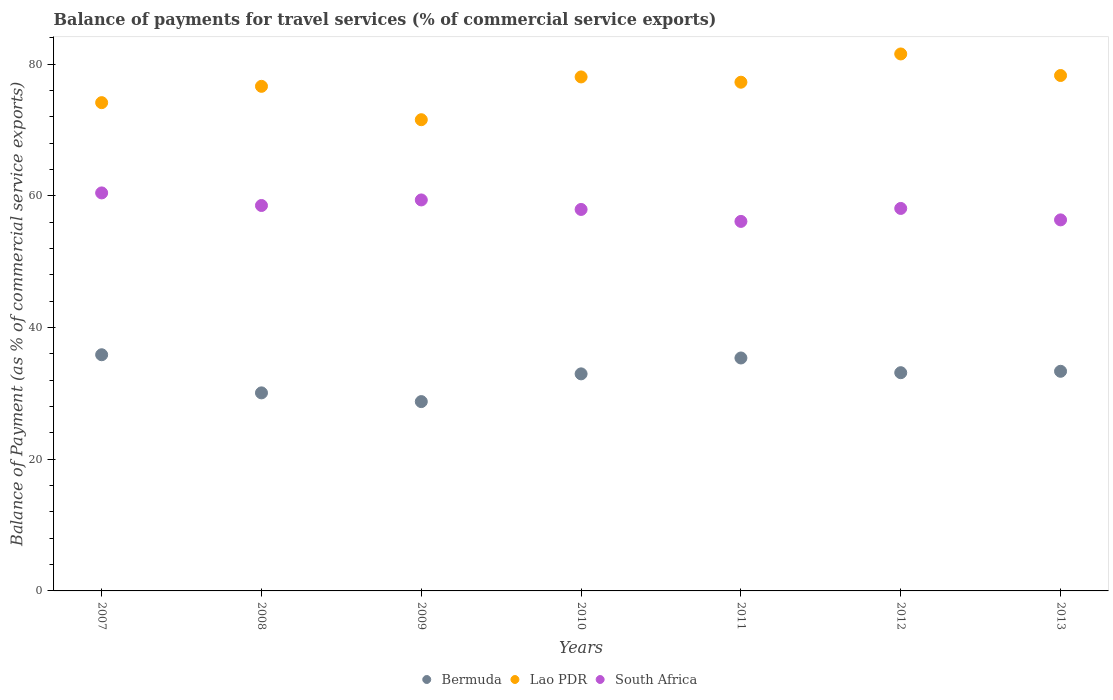How many different coloured dotlines are there?
Provide a short and direct response. 3. What is the balance of payments for travel services in Bermuda in 2009?
Offer a very short reply. 28.76. Across all years, what is the maximum balance of payments for travel services in Bermuda?
Offer a very short reply. 35.88. Across all years, what is the minimum balance of payments for travel services in Bermuda?
Give a very brief answer. 28.76. What is the total balance of payments for travel services in Lao PDR in the graph?
Offer a very short reply. 537.66. What is the difference between the balance of payments for travel services in Lao PDR in 2007 and that in 2009?
Your answer should be compact. 2.59. What is the difference between the balance of payments for travel services in Bermuda in 2013 and the balance of payments for travel services in Lao PDR in 2007?
Offer a terse response. -40.81. What is the average balance of payments for travel services in South Africa per year?
Your response must be concise. 58.14. In the year 2012, what is the difference between the balance of payments for travel services in South Africa and balance of payments for travel services in Bermuda?
Your answer should be very brief. 24.95. In how many years, is the balance of payments for travel services in Lao PDR greater than 80 %?
Your answer should be very brief. 1. What is the ratio of the balance of payments for travel services in South Africa in 2007 to that in 2008?
Ensure brevity in your answer.  1.03. Is the difference between the balance of payments for travel services in South Africa in 2007 and 2009 greater than the difference between the balance of payments for travel services in Bermuda in 2007 and 2009?
Ensure brevity in your answer.  No. What is the difference between the highest and the second highest balance of payments for travel services in South Africa?
Offer a terse response. 1.07. What is the difference between the highest and the lowest balance of payments for travel services in Bermuda?
Give a very brief answer. 7.12. Is the sum of the balance of payments for travel services in South Africa in 2009 and 2011 greater than the maximum balance of payments for travel services in Lao PDR across all years?
Your response must be concise. Yes. Is the balance of payments for travel services in South Africa strictly greater than the balance of payments for travel services in Bermuda over the years?
Your response must be concise. Yes. Is the balance of payments for travel services in Bermuda strictly less than the balance of payments for travel services in South Africa over the years?
Make the answer very short. Yes. How many dotlines are there?
Your response must be concise. 3. What is the difference between two consecutive major ticks on the Y-axis?
Your answer should be very brief. 20. Where does the legend appear in the graph?
Provide a short and direct response. Bottom center. How many legend labels are there?
Offer a very short reply. 3. How are the legend labels stacked?
Ensure brevity in your answer.  Horizontal. What is the title of the graph?
Provide a short and direct response. Balance of payments for travel services (% of commercial service exports). Does "European Union" appear as one of the legend labels in the graph?
Make the answer very short. No. What is the label or title of the Y-axis?
Offer a terse response. Balance of Payment (as % of commercial service exports). What is the Balance of Payment (as % of commercial service exports) of Bermuda in 2007?
Offer a terse response. 35.88. What is the Balance of Payment (as % of commercial service exports) of Lao PDR in 2007?
Offer a very short reply. 74.18. What is the Balance of Payment (as % of commercial service exports) of South Africa in 2007?
Make the answer very short. 60.46. What is the Balance of Payment (as % of commercial service exports) of Bermuda in 2008?
Provide a succinct answer. 30.09. What is the Balance of Payment (as % of commercial service exports) of Lao PDR in 2008?
Keep it short and to the point. 76.65. What is the Balance of Payment (as % of commercial service exports) in South Africa in 2008?
Ensure brevity in your answer.  58.55. What is the Balance of Payment (as % of commercial service exports) in Bermuda in 2009?
Provide a succinct answer. 28.76. What is the Balance of Payment (as % of commercial service exports) in Lao PDR in 2009?
Provide a short and direct response. 71.58. What is the Balance of Payment (as % of commercial service exports) of South Africa in 2009?
Make the answer very short. 59.4. What is the Balance of Payment (as % of commercial service exports) in Bermuda in 2010?
Keep it short and to the point. 32.98. What is the Balance of Payment (as % of commercial service exports) of Lao PDR in 2010?
Provide a short and direct response. 78.08. What is the Balance of Payment (as % of commercial service exports) of South Africa in 2010?
Provide a short and direct response. 57.95. What is the Balance of Payment (as % of commercial service exports) in Bermuda in 2011?
Ensure brevity in your answer.  35.39. What is the Balance of Payment (as % of commercial service exports) in Lao PDR in 2011?
Offer a terse response. 77.28. What is the Balance of Payment (as % of commercial service exports) of South Africa in 2011?
Offer a terse response. 56.14. What is the Balance of Payment (as % of commercial service exports) in Bermuda in 2012?
Make the answer very short. 33.15. What is the Balance of Payment (as % of commercial service exports) in Lao PDR in 2012?
Offer a terse response. 81.57. What is the Balance of Payment (as % of commercial service exports) of South Africa in 2012?
Offer a terse response. 58.11. What is the Balance of Payment (as % of commercial service exports) in Bermuda in 2013?
Keep it short and to the point. 33.37. What is the Balance of Payment (as % of commercial service exports) in Lao PDR in 2013?
Ensure brevity in your answer.  78.3. What is the Balance of Payment (as % of commercial service exports) in South Africa in 2013?
Make the answer very short. 56.37. Across all years, what is the maximum Balance of Payment (as % of commercial service exports) of Bermuda?
Your answer should be very brief. 35.88. Across all years, what is the maximum Balance of Payment (as % of commercial service exports) of Lao PDR?
Keep it short and to the point. 81.57. Across all years, what is the maximum Balance of Payment (as % of commercial service exports) of South Africa?
Your answer should be compact. 60.46. Across all years, what is the minimum Balance of Payment (as % of commercial service exports) in Bermuda?
Your answer should be very brief. 28.76. Across all years, what is the minimum Balance of Payment (as % of commercial service exports) of Lao PDR?
Your answer should be very brief. 71.58. Across all years, what is the minimum Balance of Payment (as % of commercial service exports) in South Africa?
Offer a very short reply. 56.14. What is the total Balance of Payment (as % of commercial service exports) in Bermuda in the graph?
Your answer should be very brief. 229.61. What is the total Balance of Payment (as % of commercial service exports) of Lao PDR in the graph?
Provide a short and direct response. 537.66. What is the total Balance of Payment (as % of commercial service exports) in South Africa in the graph?
Offer a terse response. 406.98. What is the difference between the Balance of Payment (as % of commercial service exports) in Bermuda in 2007 and that in 2008?
Ensure brevity in your answer.  5.79. What is the difference between the Balance of Payment (as % of commercial service exports) in Lao PDR in 2007 and that in 2008?
Keep it short and to the point. -2.48. What is the difference between the Balance of Payment (as % of commercial service exports) of South Africa in 2007 and that in 2008?
Your answer should be very brief. 1.91. What is the difference between the Balance of Payment (as % of commercial service exports) of Bermuda in 2007 and that in 2009?
Ensure brevity in your answer.  7.12. What is the difference between the Balance of Payment (as % of commercial service exports) of Lao PDR in 2007 and that in 2009?
Ensure brevity in your answer.  2.59. What is the difference between the Balance of Payment (as % of commercial service exports) in South Africa in 2007 and that in 2009?
Offer a terse response. 1.07. What is the difference between the Balance of Payment (as % of commercial service exports) in Bermuda in 2007 and that in 2010?
Ensure brevity in your answer.  2.9. What is the difference between the Balance of Payment (as % of commercial service exports) in Lao PDR in 2007 and that in 2010?
Your response must be concise. -3.91. What is the difference between the Balance of Payment (as % of commercial service exports) of South Africa in 2007 and that in 2010?
Keep it short and to the point. 2.51. What is the difference between the Balance of Payment (as % of commercial service exports) of Bermuda in 2007 and that in 2011?
Offer a terse response. 0.49. What is the difference between the Balance of Payment (as % of commercial service exports) in Lao PDR in 2007 and that in 2011?
Offer a terse response. -3.1. What is the difference between the Balance of Payment (as % of commercial service exports) of South Africa in 2007 and that in 2011?
Make the answer very short. 4.33. What is the difference between the Balance of Payment (as % of commercial service exports) of Bermuda in 2007 and that in 2012?
Your answer should be compact. 2.73. What is the difference between the Balance of Payment (as % of commercial service exports) of Lao PDR in 2007 and that in 2012?
Keep it short and to the point. -7.4. What is the difference between the Balance of Payment (as % of commercial service exports) of South Africa in 2007 and that in 2012?
Your answer should be compact. 2.36. What is the difference between the Balance of Payment (as % of commercial service exports) of Bermuda in 2007 and that in 2013?
Provide a short and direct response. 2.51. What is the difference between the Balance of Payment (as % of commercial service exports) of Lao PDR in 2007 and that in 2013?
Your answer should be compact. -4.12. What is the difference between the Balance of Payment (as % of commercial service exports) in South Africa in 2007 and that in 2013?
Make the answer very short. 4.1. What is the difference between the Balance of Payment (as % of commercial service exports) of Bermuda in 2008 and that in 2009?
Make the answer very short. 1.33. What is the difference between the Balance of Payment (as % of commercial service exports) of Lao PDR in 2008 and that in 2009?
Offer a very short reply. 5.07. What is the difference between the Balance of Payment (as % of commercial service exports) of South Africa in 2008 and that in 2009?
Your answer should be very brief. -0.84. What is the difference between the Balance of Payment (as % of commercial service exports) of Bermuda in 2008 and that in 2010?
Your answer should be very brief. -2.89. What is the difference between the Balance of Payment (as % of commercial service exports) in Lao PDR in 2008 and that in 2010?
Your answer should be compact. -1.43. What is the difference between the Balance of Payment (as % of commercial service exports) in South Africa in 2008 and that in 2010?
Provide a short and direct response. 0.6. What is the difference between the Balance of Payment (as % of commercial service exports) of Bermuda in 2008 and that in 2011?
Keep it short and to the point. -5.3. What is the difference between the Balance of Payment (as % of commercial service exports) of Lao PDR in 2008 and that in 2011?
Ensure brevity in your answer.  -0.63. What is the difference between the Balance of Payment (as % of commercial service exports) of South Africa in 2008 and that in 2011?
Ensure brevity in your answer.  2.42. What is the difference between the Balance of Payment (as % of commercial service exports) in Bermuda in 2008 and that in 2012?
Offer a terse response. -3.06. What is the difference between the Balance of Payment (as % of commercial service exports) in Lao PDR in 2008 and that in 2012?
Ensure brevity in your answer.  -4.92. What is the difference between the Balance of Payment (as % of commercial service exports) in South Africa in 2008 and that in 2012?
Keep it short and to the point. 0.45. What is the difference between the Balance of Payment (as % of commercial service exports) in Bermuda in 2008 and that in 2013?
Your answer should be compact. -3.28. What is the difference between the Balance of Payment (as % of commercial service exports) of Lao PDR in 2008 and that in 2013?
Ensure brevity in your answer.  -1.65. What is the difference between the Balance of Payment (as % of commercial service exports) of South Africa in 2008 and that in 2013?
Give a very brief answer. 2.19. What is the difference between the Balance of Payment (as % of commercial service exports) of Bermuda in 2009 and that in 2010?
Provide a short and direct response. -4.22. What is the difference between the Balance of Payment (as % of commercial service exports) in Lao PDR in 2009 and that in 2010?
Give a very brief answer. -6.5. What is the difference between the Balance of Payment (as % of commercial service exports) in South Africa in 2009 and that in 2010?
Make the answer very short. 1.45. What is the difference between the Balance of Payment (as % of commercial service exports) of Bermuda in 2009 and that in 2011?
Your answer should be compact. -6.63. What is the difference between the Balance of Payment (as % of commercial service exports) of Lao PDR in 2009 and that in 2011?
Offer a terse response. -5.7. What is the difference between the Balance of Payment (as % of commercial service exports) in South Africa in 2009 and that in 2011?
Provide a succinct answer. 3.26. What is the difference between the Balance of Payment (as % of commercial service exports) in Bermuda in 2009 and that in 2012?
Your response must be concise. -4.39. What is the difference between the Balance of Payment (as % of commercial service exports) of Lao PDR in 2009 and that in 2012?
Your answer should be very brief. -9.99. What is the difference between the Balance of Payment (as % of commercial service exports) of South Africa in 2009 and that in 2012?
Keep it short and to the point. 1.29. What is the difference between the Balance of Payment (as % of commercial service exports) of Bermuda in 2009 and that in 2013?
Offer a terse response. -4.61. What is the difference between the Balance of Payment (as % of commercial service exports) of Lao PDR in 2009 and that in 2013?
Offer a very short reply. -6.72. What is the difference between the Balance of Payment (as % of commercial service exports) in South Africa in 2009 and that in 2013?
Your answer should be compact. 3.03. What is the difference between the Balance of Payment (as % of commercial service exports) of Bermuda in 2010 and that in 2011?
Offer a terse response. -2.41. What is the difference between the Balance of Payment (as % of commercial service exports) in Lao PDR in 2010 and that in 2011?
Make the answer very short. 0.8. What is the difference between the Balance of Payment (as % of commercial service exports) of South Africa in 2010 and that in 2011?
Ensure brevity in your answer.  1.82. What is the difference between the Balance of Payment (as % of commercial service exports) of Bermuda in 2010 and that in 2012?
Your answer should be very brief. -0.18. What is the difference between the Balance of Payment (as % of commercial service exports) of Lao PDR in 2010 and that in 2012?
Make the answer very short. -3.49. What is the difference between the Balance of Payment (as % of commercial service exports) in South Africa in 2010 and that in 2012?
Your response must be concise. -0.15. What is the difference between the Balance of Payment (as % of commercial service exports) of Bermuda in 2010 and that in 2013?
Your answer should be very brief. -0.39. What is the difference between the Balance of Payment (as % of commercial service exports) in Lao PDR in 2010 and that in 2013?
Make the answer very short. -0.22. What is the difference between the Balance of Payment (as % of commercial service exports) in South Africa in 2010 and that in 2013?
Offer a terse response. 1.58. What is the difference between the Balance of Payment (as % of commercial service exports) in Bermuda in 2011 and that in 2012?
Offer a terse response. 2.24. What is the difference between the Balance of Payment (as % of commercial service exports) of Lao PDR in 2011 and that in 2012?
Ensure brevity in your answer.  -4.29. What is the difference between the Balance of Payment (as % of commercial service exports) in South Africa in 2011 and that in 2012?
Ensure brevity in your answer.  -1.97. What is the difference between the Balance of Payment (as % of commercial service exports) of Bermuda in 2011 and that in 2013?
Give a very brief answer. 2.02. What is the difference between the Balance of Payment (as % of commercial service exports) of Lao PDR in 2011 and that in 2013?
Your answer should be compact. -1.02. What is the difference between the Balance of Payment (as % of commercial service exports) of South Africa in 2011 and that in 2013?
Your answer should be compact. -0.23. What is the difference between the Balance of Payment (as % of commercial service exports) in Bermuda in 2012 and that in 2013?
Ensure brevity in your answer.  -0.21. What is the difference between the Balance of Payment (as % of commercial service exports) in Lao PDR in 2012 and that in 2013?
Give a very brief answer. 3.27. What is the difference between the Balance of Payment (as % of commercial service exports) in South Africa in 2012 and that in 2013?
Offer a terse response. 1.74. What is the difference between the Balance of Payment (as % of commercial service exports) in Bermuda in 2007 and the Balance of Payment (as % of commercial service exports) in Lao PDR in 2008?
Give a very brief answer. -40.78. What is the difference between the Balance of Payment (as % of commercial service exports) of Bermuda in 2007 and the Balance of Payment (as % of commercial service exports) of South Africa in 2008?
Give a very brief answer. -22.67. What is the difference between the Balance of Payment (as % of commercial service exports) of Lao PDR in 2007 and the Balance of Payment (as % of commercial service exports) of South Africa in 2008?
Offer a terse response. 15.62. What is the difference between the Balance of Payment (as % of commercial service exports) of Bermuda in 2007 and the Balance of Payment (as % of commercial service exports) of Lao PDR in 2009?
Your answer should be compact. -35.71. What is the difference between the Balance of Payment (as % of commercial service exports) in Bermuda in 2007 and the Balance of Payment (as % of commercial service exports) in South Africa in 2009?
Provide a succinct answer. -23.52. What is the difference between the Balance of Payment (as % of commercial service exports) of Lao PDR in 2007 and the Balance of Payment (as % of commercial service exports) of South Africa in 2009?
Your answer should be compact. 14.78. What is the difference between the Balance of Payment (as % of commercial service exports) of Bermuda in 2007 and the Balance of Payment (as % of commercial service exports) of Lao PDR in 2010?
Offer a terse response. -42.21. What is the difference between the Balance of Payment (as % of commercial service exports) in Bermuda in 2007 and the Balance of Payment (as % of commercial service exports) in South Africa in 2010?
Offer a terse response. -22.07. What is the difference between the Balance of Payment (as % of commercial service exports) of Lao PDR in 2007 and the Balance of Payment (as % of commercial service exports) of South Africa in 2010?
Give a very brief answer. 16.23. What is the difference between the Balance of Payment (as % of commercial service exports) of Bermuda in 2007 and the Balance of Payment (as % of commercial service exports) of Lao PDR in 2011?
Offer a very short reply. -41.4. What is the difference between the Balance of Payment (as % of commercial service exports) of Bermuda in 2007 and the Balance of Payment (as % of commercial service exports) of South Africa in 2011?
Offer a terse response. -20.26. What is the difference between the Balance of Payment (as % of commercial service exports) in Lao PDR in 2007 and the Balance of Payment (as % of commercial service exports) in South Africa in 2011?
Your answer should be very brief. 18.04. What is the difference between the Balance of Payment (as % of commercial service exports) in Bermuda in 2007 and the Balance of Payment (as % of commercial service exports) in Lao PDR in 2012?
Your answer should be very brief. -45.7. What is the difference between the Balance of Payment (as % of commercial service exports) of Bermuda in 2007 and the Balance of Payment (as % of commercial service exports) of South Africa in 2012?
Provide a short and direct response. -22.23. What is the difference between the Balance of Payment (as % of commercial service exports) of Lao PDR in 2007 and the Balance of Payment (as % of commercial service exports) of South Africa in 2012?
Ensure brevity in your answer.  16.07. What is the difference between the Balance of Payment (as % of commercial service exports) of Bermuda in 2007 and the Balance of Payment (as % of commercial service exports) of Lao PDR in 2013?
Keep it short and to the point. -42.42. What is the difference between the Balance of Payment (as % of commercial service exports) in Bermuda in 2007 and the Balance of Payment (as % of commercial service exports) in South Africa in 2013?
Offer a terse response. -20.49. What is the difference between the Balance of Payment (as % of commercial service exports) of Lao PDR in 2007 and the Balance of Payment (as % of commercial service exports) of South Africa in 2013?
Your response must be concise. 17.81. What is the difference between the Balance of Payment (as % of commercial service exports) of Bermuda in 2008 and the Balance of Payment (as % of commercial service exports) of Lao PDR in 2009?
Your response must be concise. -41.5. What is the difference between the Balance of Payment (as % of commercial service exports) in Bermuda in 2008 and the Balance of Payment (as % of commercial service exports) in South Africa in 2009?
Make the answer very short. -29.31. What is the difference between the Balance of Payment (as % of commercial service exports) of Lao PDR in 2008 and the Balance of Payment (as % of commercial service exports) of South Africa in 2009?
Provide a succinct answer. 17.26. What is the difference between the Balance of Payment (as % of commercial service exports) in Bermuda in 2008 and the Balance of Payment (as % of commercial service exports) in Lao PDR in 2010?
Your response must be concise. -48. What is the difference between the Balance of Payment (as % of commercial service exports) in Bermuda in 2008 and the Balance of Payment (as % of commercial service exports) in South Africa in 2010?
Your answer should be compact. -27.86. What is the difference between the Balance of Payment (as % of commercial service exports) of Lao PDR in 2008 and the Balance of Payment (as % of commercial service exports) of South Africa in 2010?
Your answer should be compact. 18.7. What is the difference between the Balance of Payment (as % of commercial service exports) in Bermuda in 2008 and the Balance of Payment (as % of commercial service exports) in Lao PDR in 2011?
Your answer should be very brief. -47.19. What is the difference between the Balance of Payment (as % of commercial service exports) in Bermuda in 2008 and the Balance of Payment (as % of commercial service exports) in South Africa in 2011?
Your answer should be compact. -26.05. What is the difference between the Balance of Payment (as % of commercial service exports) in Lao PDR in 2008 and the Balance of Payment (as % of commercial service exports) in South Africa in 2011?
Ensure brevity in your answer.  20.52. What is the difference between the Balance of Payment (as % of commercial service exports) in Bermuda in 2008 and the Balance of Payment (as % of commercial service exports) in Lao PDR in 2012?
Offer a terse response. -51.49. What is the difference between the Balance of Payment (as % of commercial service exports) in Bermuda in 2008 and the Balance of Payment (as % of commercial service exports) in South Africa in 2012?
Keep it short and to the point. -28.02. What is the difference between the Balance of Payment (as % of commercial service exports) of Lao PDR in 2008 and the Balance of Payment (as % of commercial service exports) of South Africa in 2012?
Offer a very short reply. 18.55. What is the difference between the Balance of Payment (as % of commercial service exports) in Bermuda in 2008 and the Balance of Payment (as % of commercial service exports) in Lao PDR in 2013?
Ensure brevity in your answer.  -48.21. What is the difference between the Balance of Payment (as % of commercial service exports) of Bermuda in 2008 and the Balance of Payment (as % of commercial service exports) of South Africa in 2013?
Offer a very short reply. -26.28. What is the difference between the Balance of Payment (as % of commercial service exports) in Lao PDR in 2008 and the Balance of Payment (as % of commercial service exports) in South Africa in 2013?
Give a very brief answer. 20.29. What is the difference between the Balance of Payment (as % of commercial service exports) of Bermuda in 2009 and the Balance of Payment (as % of commercial service exports) of Lao PDR in 2010?
Make the answer very short. -49.32. What is the difference between the Balance of Payment (as % of commercial service exports) of Bermuda in 2009 and the Balance of Payment (as % of commercial service exports) of South Africa in 2010?
Your answer should be very brief. -29.19. What is the difference between the Balance of Payment (as % of commercial service exports) of Lao PDR in 2009 and the Balance of Payment (as % of commercial service exports) of South Africa in 2010?
Keep it short and to the point. 13.63. What is the difference between the Balance of Payment (as % of commercial service exports) of Bermuda in 2009 and the Balance of Payment (as % of commercial service exports) of Lao PDR in 2011?
Make the answer very short. -48.52. What is the difference between the Balance of Payment (as % of commercial service exports) of Bermuda in 2009 and the Balance of Payment (as % of commercial service exports) of South Africa in 2011?
Your answer should be compact. -27.38. What is the difference between the Balance of Payment (as % of commercial service exports) of Lao PDR in 2009 and the Balance of Payment (as % of commercial service exports) of South Africa in 2011?
Your response must be concise. 15.45. What is the difference between the Balance of Payment (as % of commercial service exports) in Bermuda in 2009 and the Balance of Payment (as % of commercial service exports) in Lao PDR in 2012?
Make the answer very short. -52.81. What is the difference between the Balance of Payment (as % of commercial service exports) of Bermuda in 2009 and the Balance of Payment (as % of commercial service exports) of South Africa in 2012?
Give a very brief answer. -29.35. What is the difference between the Balance of Payment (as % of commercial service exports) in Lao PDR in 2009 and the Balance of Payment (as % of commercial service exports) in South Africa in 2012?
Ensure brevity in your answer.  13.48. What is the difference between the Balance of Payment (as % of commercial service exports) of Bermuda in 2009 and the Balance of Payment (as % of commercial service exports) of Lao PDR in 2013?
Provide a succinct answer. -49.54. What is the difference between the Balance of Payment (as % of commercial service exports) of Bermuda in 2009 and the Balance of Payment (as % of commercial service exports) of South Africa in 2013?
Your response must be concise. -27.61. What is the difference between the Balance of Payment (as % of commercial service exports) of Lao PDR in 2009 and the Balance of Payment (as % of commercial service exports) of South Africa in 2013?
Your response must be concise. 15.22. What is the difference between the Balance of Payment (as % of commercial service exports) in Bermuda in 2010 and the Balance of Payment (as % of commercial service exports) in Lao PDR in 2011?
Your response must be concise. -44.31. What is the difference between the Balance of Payment (as % of commercial service exports) in Bermuda in 2010 and the Balance of Payment (as % of commercial service exports) in South Africa in 2011?
Give a very brief answer. -23.16. What is the difference between the Balance of Payment (as % of commercial service exports) in Lao PDR in 2010 and the Balance of Payment (as % of commercial service exports) in South Africa in 2011?
Make the answer very short. 21.95. What is the difference between the Balance of Payment (as % of commercial service exports) of Bermuda in 2010 and the Balance of Payment (as % of commercial service exports) of Lao PDR in 2012?
Ensure brevity in your answer.  -48.6. What is the difference between the Balance of Payment (as % of commercial service exports) of Bermuda in 2010 and the Balance of Payment (as % of commercial service exports) of South Africa in 2012?
Provide a succinct answer. -25.13. What is the difference between the Balance of Payment (as % of commercial service exports) of Lao PDR in 2010 and the Balance of Payment (as % of commercial service exports) of South Africa in 2012?
Your answer should be very brief. 19.98. What is the difference between the Balance of Payment (as % of commercial service exports) in Bermuda in 2010 and the Balance of Payment (as % of commercial service exports) in Lao PDR in 2013?
Your answer should be very brief. -45.33. What is the difference between the Balance of Payment (as % of commercial service exports) of Bermuda in 2010 and the Balance of Payment (as % of commercial service exports) of South Africa in 2013?
Provide a succinct answer. -23.39. What is the difference between the Balance of Payment (as % of commercial service exports) in Lao PDR in 2010 and the Balance of Payment (as % of commercial service exports) in South Africa in 2013?
Provide a short and direct response. 21.72. What is the difference between the Balance of Payment (as % of commercial service exports) of Bermuda in 2011 and the Balance of Payment (as % of commercial service exports) of Lao PDR in 2012?
Offer a very short reply. -46.19. What is the difference between the Balance of Payment (as % of commercial service exports) of Bermuda in 2011 and the Balance of Payment (as % of commercial service exports) of South Africa in 2012?
Your answer should be very brief. -22.72. What is the difference between the Balance of Payment (as % of commercial service exports) in Lao PDR in 2011 and the Balance of Payment (as % of commercial service exports) in South Africa in 2012?
Your answer should be very brief. 19.18. What is the difference between the Balance of Payment (as % of commercial service exports) of Bermuda in 2011 and the Balance of Payment (as % of commercial service exports) of Lao PDR in 2013?
Offer a very short reply. -42.91. What is the difference between the Balance of Payment (as % of commercial service exports) of Bermuda in 2011 and the Balance of Payment (as % of commercial service exports) of South Africa in 2013?
Your answer should be compact. -20.98. What is the difference between the Balance of Payment (as % of commercial service exports) in Lao PDR in 2011 and the Balance of Payment (as % of commercial service exports) in South Africa in 2013?
Your answer should be very brief. 20.91. What is the difference between the Balance of Payment (as % of commercial service exports) of Bermuda in 2012 and the Balance of Payment (as % of commercial service exports) of Lao PDR in 2013?
Offer a very short reply. -45.15. What is the difference between the Balance of Payment (as % of commercial service exports) in Bermuda in 2012 and the Balance of Payment (as % of commercial service exports) in South Africa in 2013?
Provide a succinct answer. -23.22. What is the difference between the Balance of Payment (as % of commercial service exports) of Lao PDR in 2012 and the Balance of Payment (as % of commercial service exports) of South Africa in 2013?
Provide a short and direct response. 25.21. What is the average Balance of Payment (as % of commercial service exports) of Bermuda per year?
Your answer should be compact. 32.8. What is the average Balance of Payment (as % of commercial service exports) of Lao PDR per year?
Your response must be concise. 76.81. What is the average Balance of Payment (as % of commercial service exports) in South Africa per year?
Give a very brief answer. 58.14. In the year 2007, what is the difference between the Balance of Payment (as % of commercial service exports) in Bermuda and Balance of Payment (as % of commercial service exports) in Lao PDR?
Offer a very short reply. -38.3. In the year 2007, what is the difference between the Balance of Payment (as % of commercial service exports) in Bermuda and Balance of Payment (as % of commercial service exports) in South Africa?
Offer a very short reply. -24.59. In the year 2007, what is the difference between the Balance of Payment (as % of commercial service exports) of Lao PDR and Balance of Payment (as % of commercial service exports) of South Africa?
Make the answer very short. 13.71. In the year 2008, what is the difference between the Balance of Payment (as % of commercial service exports) in Bermuda and Balance of Payment (as % of commercial service exports) in Lao PDR?
Offer a terse response. -46.57. In the year 2008, what is the difference between the Balance of Payment (as % of commercial service exports) of Bermuda and Balance of Payment (as % of commercial service exports) of South Africa?
Your answer should be compact. -28.47. In the year 2008, what is the difference between the Balance of Payment (as % of commercial service exports) of Lao PDR and Balance of Payment (as % of commercial service exports) of South Africa?
Provide a succinct answer. 18.1. In the year 2009, what is the difference between the Balance of Payment (as % of commercial service exports) in Bermuda and Balance of Payment (as % of commercial service exports) in Lao PDR?
Give a very brief answer. -42.82. In the year 2009, what is the difference between the Balance of Payment (as % of commercial service exports) of Bermuda and Balance of Payment (as % of commercial service exports) of South Africa?
Keep it short and to the point. -30.64. In the year 2009, what is the difference between the Balance of Payment (as % of commercial service exports) of Lao PDR and Balance of Payment (as % of commercial service exports) of South Africa?
Keep it short and to the point. 12.19. In the year 2010, what is the difference between the Balance of Payment (as % of commercial service exports) in Bermuda and Balance of Payment (as % of commercial service exports) in Lao PDR?
Provide a short and direct response. -45.11. In the year 2010, what is the difference between the Balance of Payment (as % of commercial service exports) of Bermuda and Balance of Payment (as % of commercial service exports) of South Africa?
Give a very brief answer. -24.98. In the year 2010, what is the difference between the Balance of Payment (as % of commercial service exports) of Lao PDR and Balance of Payment (as % of commercial service exports) of South Africa?
Ensure brevity in your answer.  20.13. In the year 2011, what is the difference between the Balance of Payment (as % of commercial service exports) in Bermuda and Balance of Payment (as % of commercial service exports) in Lao PDR?
Offer a terse response. -41.89. In the year 2011, what is the difference between the Balance of Payment (as % of commercial service exports) of Bermuda and Balance of Payment (as % of commercial service exports) of South Africa?
Ensure brevity in your answer.  -20.75. In the year 2011, what is the difference between the Balance of Payment (as % of commercial service exports) in Lao PDR and Balance of Payment (as % of commercial service exports) in South Africa?
Offer a very short reply. 21.15. In the year 2012, what is the difference between the Balance of Payment (as % of commercial service exports) in Bermuda and Balance of Payment (as % of commercial service exports) in Lao PDR?
Give a very brief answer. -48.42. In the year 2012, what is the difference between the Balance of Payment (as % of commercial service exports) in Bermuda and Balance of Payment (as % of commercial service exports) in South Africa?
Offer a very short reply. -24.95. In the year 2012, what is the difference between the Balance of Payment (as % of commercial service exports) in Lao PDR and Balance of Payment (as % of commercial service exports) in South Africa?
Provide a succinct answer. 23.47. In the year 2013, what is the difference between the Balance of Payment (as % of commercial service exports) in Bermuda and Balance of Payment (as % of commercial service exports) in Lao PDR?
Offer a terse response. -44.93. In the year 2013, what is the difference between the Balance of Payment (as % of commercial service exports) in Bermuda and Balance of Payment (as % of commercial service exports) in South Africa?
Offer a terse response. -23. In the year 2013, what is the difference between the Balance of Payment (as % of commercial service exports) in Lao PDR and Balance of Payment (as % of commercial service exports) in South Africa?
Give a very brief answer. 21.93. What is the ratio of the Balance of Payment (as % of commercial service exports) of Bermuda in 2007 to that in 2008?
Your answer should be very brief. 1.19. What is the ratio of the Balance of Payment (as % of commercial service exports) of South Africa in 2007 to that in 2008?
Offer a terse response. 1.03. What is the ratio of the Balance of Payment (as % of commercial service exports) of Bermuda in 2007 to that in 2009?
Offer a terse response. 1.25. What is the ratio of the Balance of Payment (as % of commercial service exports) of Lao PDR in 2007 to that in 2009?
Keep it short and to the point. 1.04. What is the ratio of the Balance of Payment (as % of commercial service exports) in Bermuda in 2007 to that in 2010?
Offer a very short reply. 1.09. What is the ratio of the Balance of Payment (as % of commercial service exports) of South Africa in 2007 to that in 2010?
Keep it short and to the point. 1.04. What is the ratio of the Balance of Payment (as % of commercial service exports) in Bermuda in 2007 to that in 2011?
Your response must be concise. 1.01. What is the ratio of the Balance of Payment (as % of commercial service exports) in Lao PDR in 2007 to that in 2011?
Offer a very short reply. 0.96. What is the ratio of the Balance of Payment (as % of commercial service exports) of South Africa in 2007 to that in 2011?
Your response must be concise. 1.08. What is the ratio of the Balance of Payment (as % of commercial service exports) of Bermuda in 2007 to that in 2012?
Provide a succinct answer. 1.08. What is the ratio of the Balance of Payment (as % of commercial service exports) in Lao PDR in 2007 to that in 2012?
Your answer should be compact. 0.91. What is the ratio of the Balance of Payment (as % of commercial service exports) of South Africa in 2007 to that in 2012?
Keep it short and to the point. 1.04. What is the ratio of the Balance of Payment (as % of commercial service exports) in Bermuda in 2007 to that in 2013?
Keep it short and to the point. 1.08. What is the ratio of the Balance of Payment (as % of commercial service exports) of Lao PDR in 2007 to that in 2013?
Your answer should be very brief. 0.95. What is the ratio of the Balance of Payment (as % of commercial service exports) of South Africa in 2007 to that in 2013?
Your response must be concise. 1.07. What is the ratio of the Balance of Payment (as % of commercial service exports) of Bermuda in 2008 to that in 2009?
Your response must be concise. 1.05. What is the ratio of the Balance of Payment (as % of commercial service exports) in Lao PDR in 2008 to that in 2009?
Offer a terse response. 1.07. What is the ratio of the Balance of Payment (as % of commercial service exports) in South Africa in 2008 to that in 2009?
Make the answer very short. 0.99. What is the ratio of the Balance of Payment (as % of commercial service exports) in Bermuda in 2008 to that in 2010?
Provide a succinct answer. 0.91. What is the ratio of the Balance of Payment (as % of commercial service exports) in Lao PDR in 2008 to that in 2010?
Keep it short and to the point. 0.98. What is the ratio of the Balance of Payment (as % of commercial service exports) of South Africa in 2008 to that in 2010?
Make the answer very short. 1.01. What is the ratio of the Balance of Payment (as % of commercial service exports) in Bermuda in 2008 to that in 2011?
Your answer should be compact. 0.85. What is the ratio of the Balance of Payment (as % of commercial service exports) in Lao PDR in 2008 to that in 2011?
Offer a terse response. 0.99. What is the ratio of the Balance of Payment (as % of commercial service exports) of South Africa in 2008 to that in 2011?
Your answer should be compact. 1.04. What is the ratio of the Balance of Payment (as % of commercial service exports) of Bermuda in 2008 to that in 2012?
Provide a short and direct response. 0.91. What is the ratio of the Balance of Payment (as % of commercial service exports) in Lao PDR in 2008 to that in 2012?
Your answer should be very brief. 0.94. What is the ratio of the Balance of Payment (as % of commercial service exports) in South Africa in 2008 to that in 2012?
Provide a succinct answer. 1.01. What is the ratio of the Balance of Payment (as % of commercial service exports) of Bermuda in 2008 to that in 2013?
Offer a very short reply. 0.9. What is the ratio of the Balance of Payment (as % of commercial service exports) of Lao PDR in 2008 to that in 2013?
Provide a short and direct response. 0.98. What is the ratio of the Balance of Payment (as % of commercial service exports) of South Africa in 2008 to that in 2013?
Ensure brevity in your answer.  1.04. What is the ratio of the Balance of Payment (as % of commercial service exports) of Bermuda in 2009 to that in 2010?
Make the answer very short. 0.87. What is the ratio of the Balance of Payment (as % of commercial service exports) of Lao PDR in 2009 to that in 2010?
Make the answer very short. 0.92. What is the ratio of the Balance of Payment (as % of commercial service exports) of South Africa in 2009 to that in 2010?
Your answer should be compact. 1.02. What is the ratio of the Balance of Payment (as % of commercial service exports) of Bermuda in 2009 to that in 2011?
Give a very brief answer. 0.81. What is the ratio of the Balance of Payment (as % of commercial service exports) in Lao PDR in 2009 to that in 2011?
Your answer should be compact. 0.93. What is the ratio of the Balance of Payment (as % of commercial service exports) of South Africa in 2009 to that in 2011?
Your answer should be very brief. 1.06. What is the ratio of the Balance of Payment (as % of commercial service exports) of Bermuda in 2009 to that in 2012?
Provide a succinct answer. 0.87. What is the ratio of the Balance of Payment (as % of commercial service exports) of Lao PDR in 2009 to that in 2012?
Make the answer very short. 0.88. What is the ratio of the Balance of Payment (as % of commercial service exports) in South Africa in 2009 to that in 2012?
Provide a succinct answer. 1.02. What is the ratio of the Balance of Payment (as % of commercial service exports) of Bermuda in 2009 to that in 2013?
Make the answer very short. 0.86. What is the ratio of the Balance of Payment (as % of commercial service exports) of Lao PDR in 2009 to that in 2013?
Ensure brevity in your answer.  0.91. What is the ratio of the Balance of Payment (as % of commercial service exports) of South Africa in 2009 to that in 2013?
Keep it short and to the point. 1.05. What is the ratio of the Balance of Payment (as % of commercial service exports) of Bermuda in 2010 to that in 2011?
Make the answer very short. 0.93. What is the ratio of the Balance of Payment (as % of commercial service exports) in Lao PDR in 2010 to that in 2011?
Provide a short and direct response. 1.01. What is the ratio of the Balance of Payment (as % of commercial service exports) in South Africa in 2010 to that in 2011?
Your answer should be compact. 1.03. What is the ratio of the Balance of Payment (as % of commercial service exports) of Bermuda in 2010 to that in 2012?
Provide a succinct answer. 0.99. What is the ratio of the Balance of Payment (as % of commercial service exports) of Lao PDR in 2010 to that in 2012?
Provide a short and direct response. 0.96. What is the ratio of the Balance of Payment (as % of commercial service exports) of South Africa in 2010 to that in 2012?
Your answer should be compact. 1. What is the ratio of the Balance of Payment (as % of commercial service exports) in Bermuda in 2010 to that in 2013?
Offer a terse response. 0.99. What is the ratio of the Balance of Payment (as % of commercial service exports) in South Africa in 2010 to that in 2013?
Provide a succinct answer. 1.03. What is the ratio of the Balance of Payment (as % of commercial service exports) of Bermuda in 2011 to that in 2012?
Offer a very short reply. 1.07. What is the ratio of the Balance of Payment (as % of commercial service exports) in South Africa in 2011 to that in 2012?
Offer a terse response. 0.97. What is the ratio of the Balance of Payment (as % of commercial service exports) in Bermuda in 2011 to that in 2013?
Keep it short and to the point. 1.06. What is the ratio of the Balance of Payment (as % of commercial service exports) of Lao PDR in 2011 to that in 2013?
Make the answer very short. 0.99. What is the ratio of the Balance of Payment (as % of commercial service exports) in Bermuda in 2012 to that in 2013?
Provide a short and direct response. 0.99. What is the ratio of the Balance of Payment (as % of commercial service exports) in Lao PDR in 2012 to that in 2013?
Give a very brief answer. 1.04. What is the ratio of the Balance of Payment (as % of commercial service exports) of South Africa in 2012 to that in 2013?
Offer a very short reply. 1.03. What is the difference between the highest and the second highest Balance of Payment (as % of commercial service exports) of Bermuda?
Keep it short and to the point. 0.49. What is the difference between the highest and the second highest Balance of Payment (as % of commercial service exports) in Lao PDR?
Keep it short and to the point. 3.27. What is the difference between the highest and the second highest Balance of Payment (as % of commercial service exports) in South Africa?
Offer a very short reply. 1.07. What is the difference between the highest and the lowest Balance of Payment (as % of commercial service exports) in Bermuda?
Your answer should be compact. 7.12. What is the difference between the highest and the lowest Balance of Payment (as % of commercial service exports) in Lao PDR?
Offer a terse response. 9.99. What is the difference between the highest and the lowest Balance of Payment (as % of commercial service exports) in South Africa?
Provide a short and direct response. 4.33. 